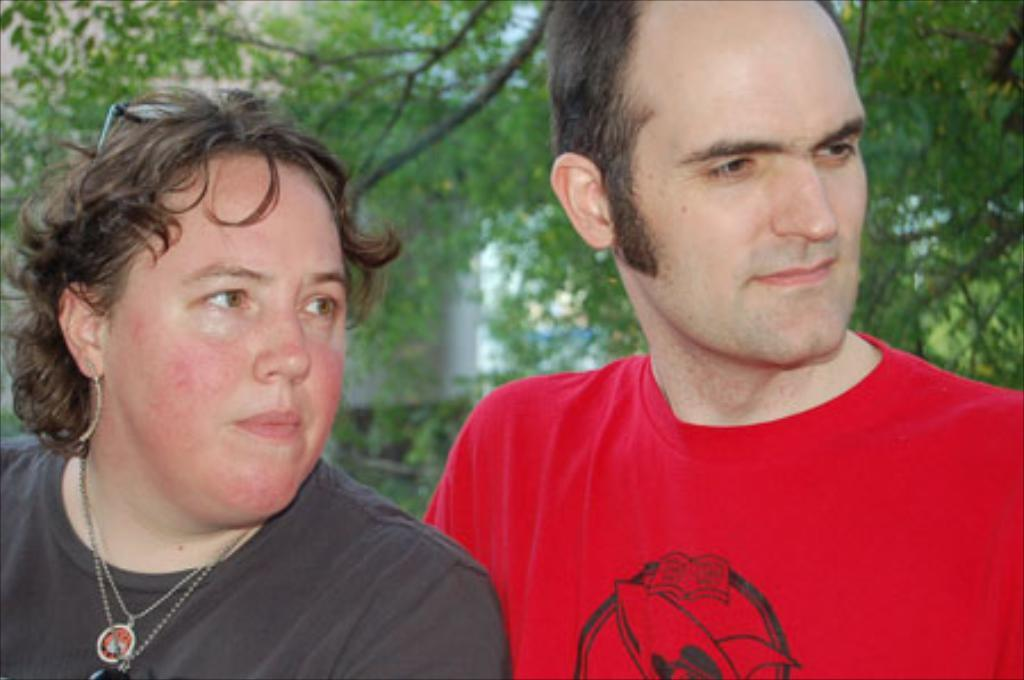How many people are present in the image? There are two people standing in the image. What can be seen in the background of the image? There is a building and a big tree in the background of the image. What flavor of note can be seen on the calendar in the image? There is no note or calendar present in the image. 